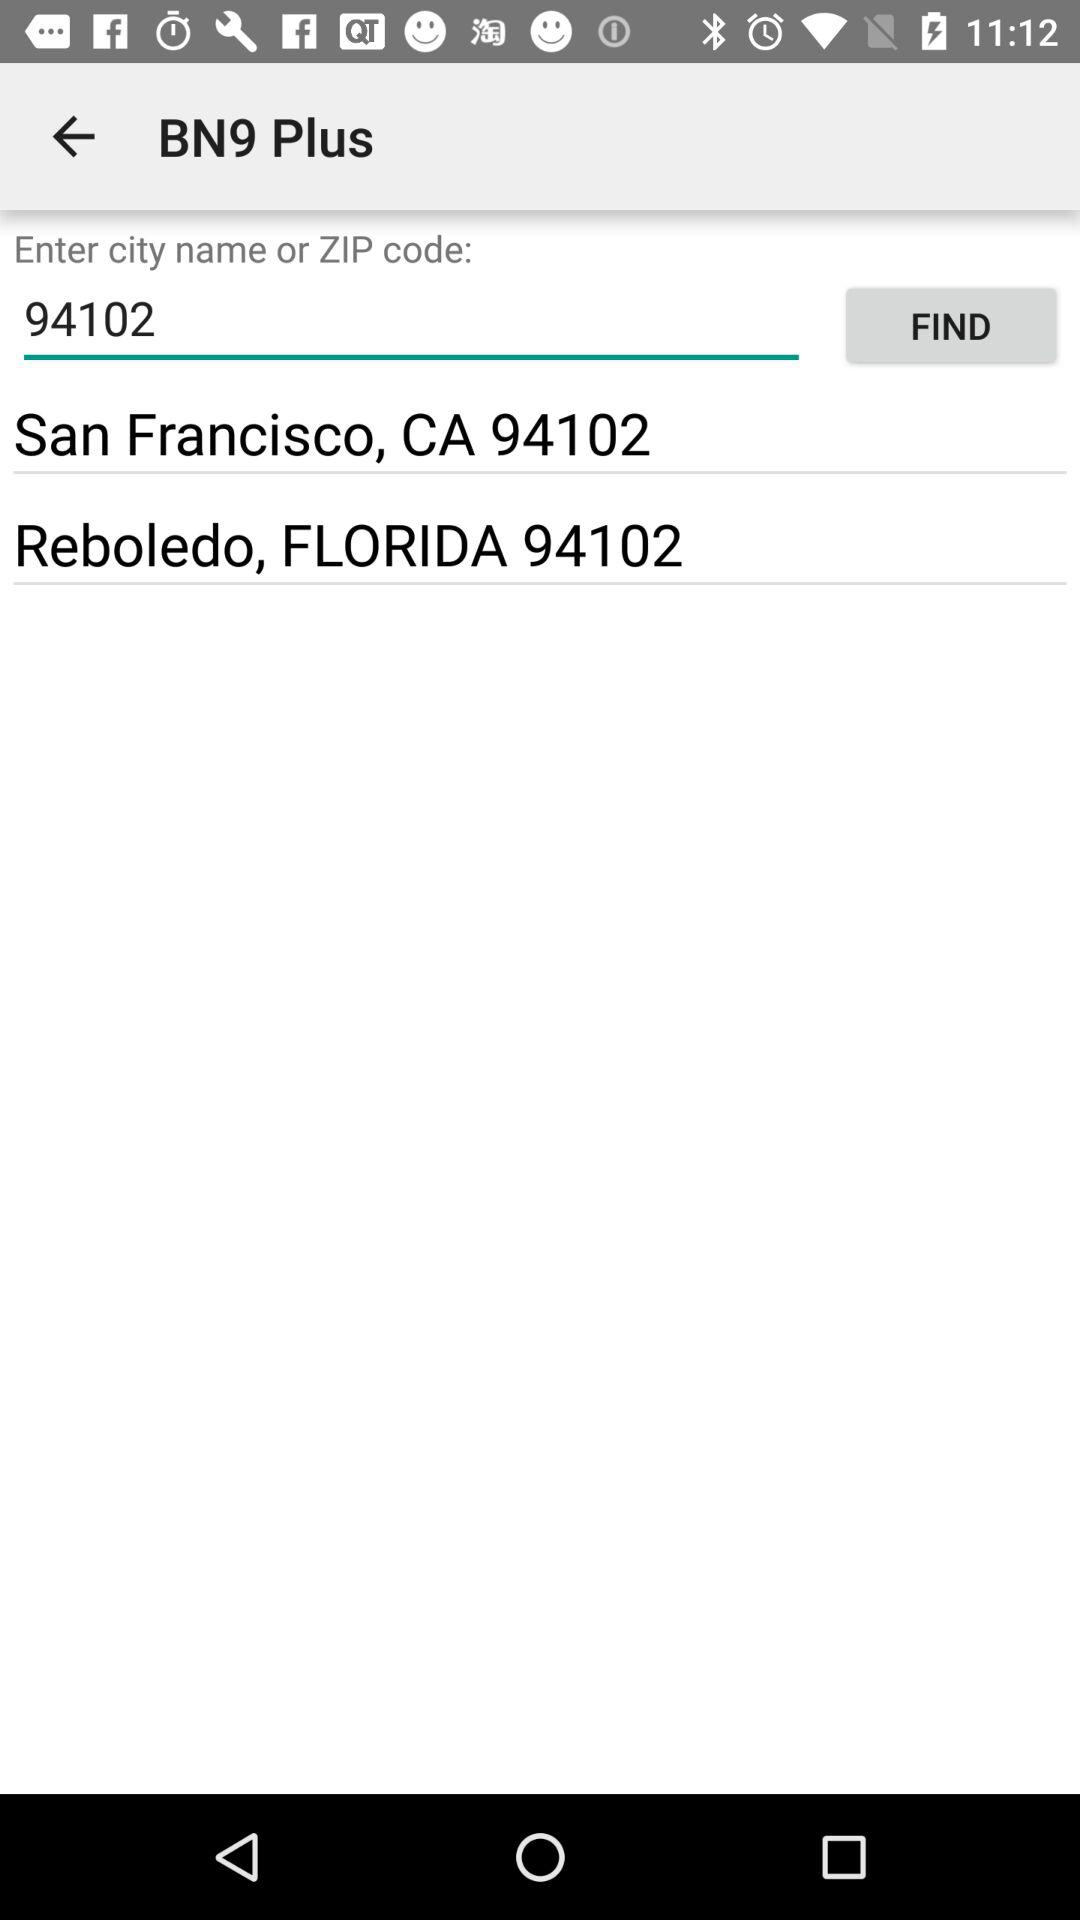How many cities are in the search results?
Answer the question using a single word or phrase. 2 